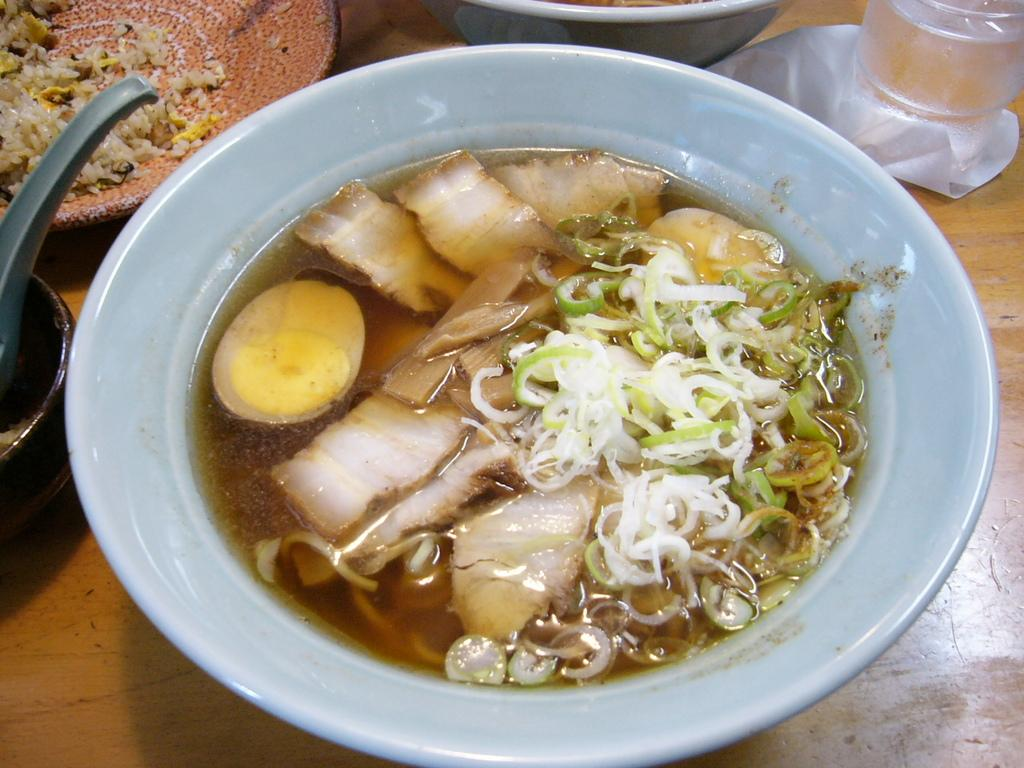What type of dishware can be seen in the image? There are bowls and a plate containing food in the image. What utensil is visible in the image? A spoon is visible in the image. Where is the glass located in the image? The glass is in the top right corner of the image. What is used to absorb moisture or clean under the glass? A tissue paper is present under the glass. What type of lipstick is being used on the plate in the image? There is no lipstick or any indication of makeup in the image; it features bowls, a plate containing food, a spoon, a glass, and a tissue paper. 